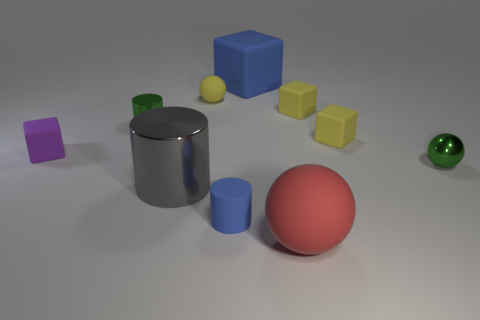What is the shape of the small thing that is the same color as the tiny metal cylinder?
Provide a succinct answer. Sphere. There is a object that is the same color as the metal sphere; what size is it?
Make the answer very short. Small. What is the cylinder to the right of the large shiny thing to the left of the big block made of?
Make the answer very short. Rubber. How many large matte things have the same color as the tiny shiny sphere?
Your answer should be compact. 0. What is the size of the sphere that is the same material as the gray thing?
Provide a succinct answer. Small. There is a green metallic object that is behind the green shiny ball; what shape is it?
Offer a very short reply. Cylinder. The other metal object that is the same shape as the large red object is what size?
Make the answer very short. Small. How many purple cubes are on the right side of the yellow thing in front of the shiny object that is left of the large gray metallic object?
Keep it short and to the point. 0. Are there an equal number of purple objects that are to the right of the large gray thing and tiny gray matte cylinders?
Make the answer very short. Yes. How many spheres are small yellow things or tiny metallic things?
Your response must be concise. 2. 